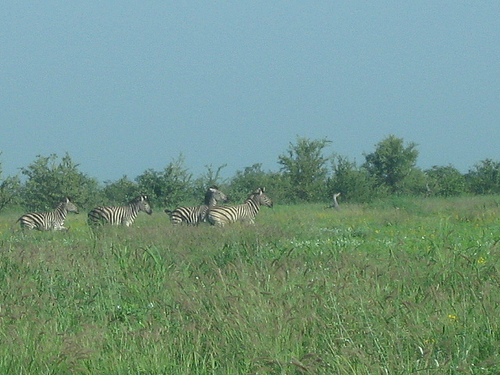<image>Where is the giraffe? There is no giraffe in the image. However, it is said that it may be in a field. Where is the giraffe? The giraffe is not in the picture. 